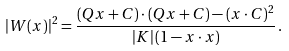<formula> <loc_0><loc_0><loc_500><loc_500>| W ( x ) | ^ { 2 } = \frac { ( Q x + C ) \cdot ( Q x + C ) - ( x \cdot C ) ^ { 2 } } { | K | \, ( 1 - x \cdot x ) } \, .</formula> 